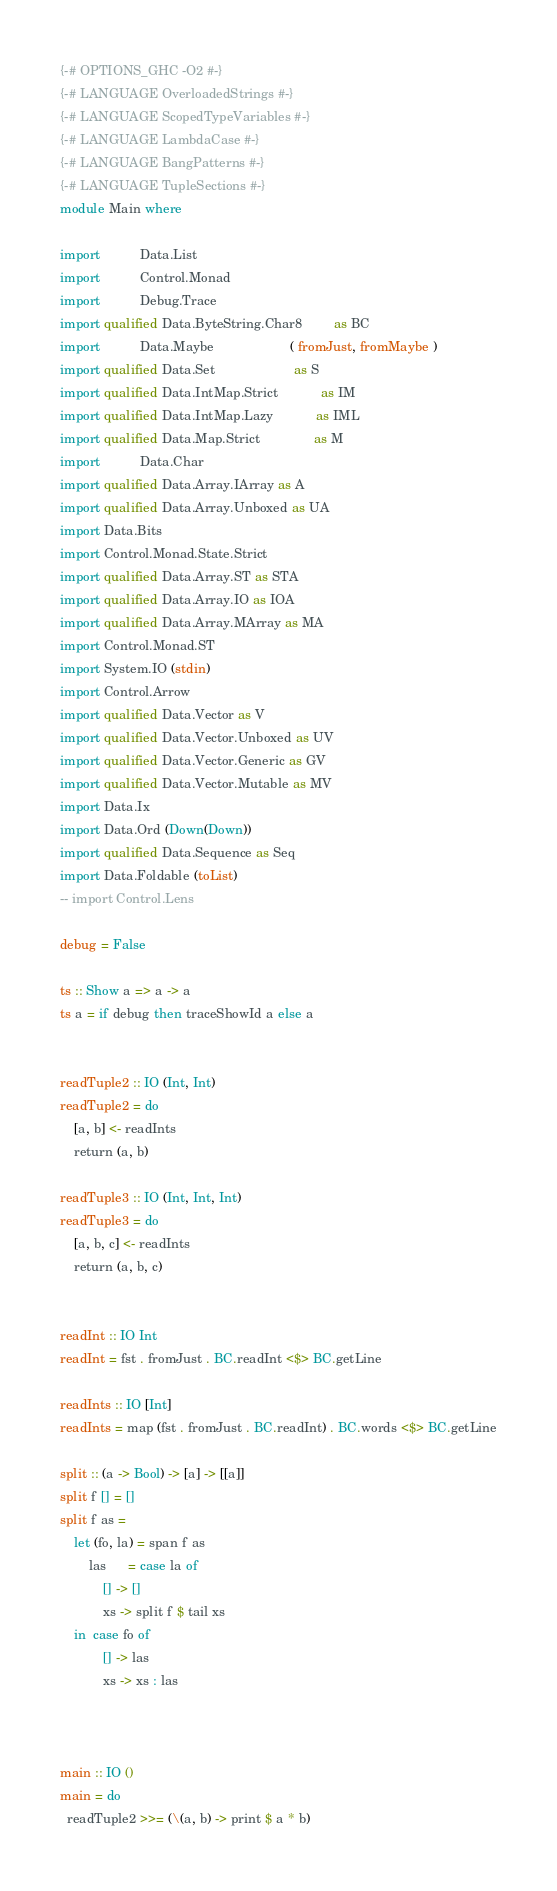Convert code to text. <code><loc_0><loc_0><loc_500><loc_500><_Haskell_>{-# OPTIONS_GHC -O2 #-}
{-# LANGUAGE OverloadedStrings #-}
{-# LANGUAGE ScopedTypeVariables #-}
{-# LANGUAGE LambdaCase #-}
{-# LANGUAGE BangPatterns #-}
{-# LANGUAGE TupleSections #-}
module Main where

import           Data.List
import           Control.Monad
import           Debug.Trace
import qualified Data.ByteString.Char8         as BC
import           Data.Maybe                     ( fromJust, fromMaybe )
import qualified Data.Set                      as S
import qualified Data.IntMap.Strict            as IM
import qualified Data.IntMap.Lazy            as IML
import qualified Data.Map.Strict               as M
import           Data.Char
import qualified Data.Array.IArray as A
import qualified Data.Array.Unboxed as UA
import Data.Bits
import Control.Monad.State.Strict
import qualified Data.Array.ST as STA
import qualified Data.Array.IO as IOA
import qualified Data.Array.MArray as MA
import Control.Monad.ST
import System.IO (stdin)
import Control.Arrow
import qualified Data.Vector as V
import qualified Data.Vector.Unboxed as UV
import qualified Data.Vector.Generic as GV
import qualified Data.Vector.Mutable as MV
import Data.Ix
import Data.Ord (Down(Down))
import qualified Data.Sequence as Seq
import Data.Foldable (toList)
-- import Control.Lens

debug = False

ts :: Show a => a -> a
ts a = if debug then traceShowId a else a


readTuple2 :: IO (Int, Int)
readTuple2 = do
    [a, b] <- readInts
    return (a, b)

readTuple3 :: IO (Int, Int, Int)
readTuple3 = do
    [a, b, c] <- readInts
    return (a, b, c)


readInt :: IO Int
readInt = fst . fromJust . BC.readInt <$> BC.getLine

readInts :: IO [Int]
readInts = map (fst . fromJust . BC.readInt) . BC.words <$> BC.getLine

split :: (a -> Bool) -> [a] -> [[a]]
split f [] = []
split f as =
    let (fo, la) = span f as
        las      = case la of
            [] -> []
            xs -> split f $ tail xs
    in  case fo of
            [] -> las
            xs -> xs : las



main :: IO ()
main = do
  readTuple2 >>= (\(a, b) -> print $ a * b)



</code> 